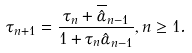Convert formula to latex. <formula><loc_0><loc_0><loc_500><loc_500>\tau _ { n + 1 } = \frac { \tau _ { n } + \overline { \hat { \alpha } } _ { n - 1 } } { 1 + \tau _ { n } \hat { \alpha } _ { n - 1 } } , n \geq 1 .</formula> 